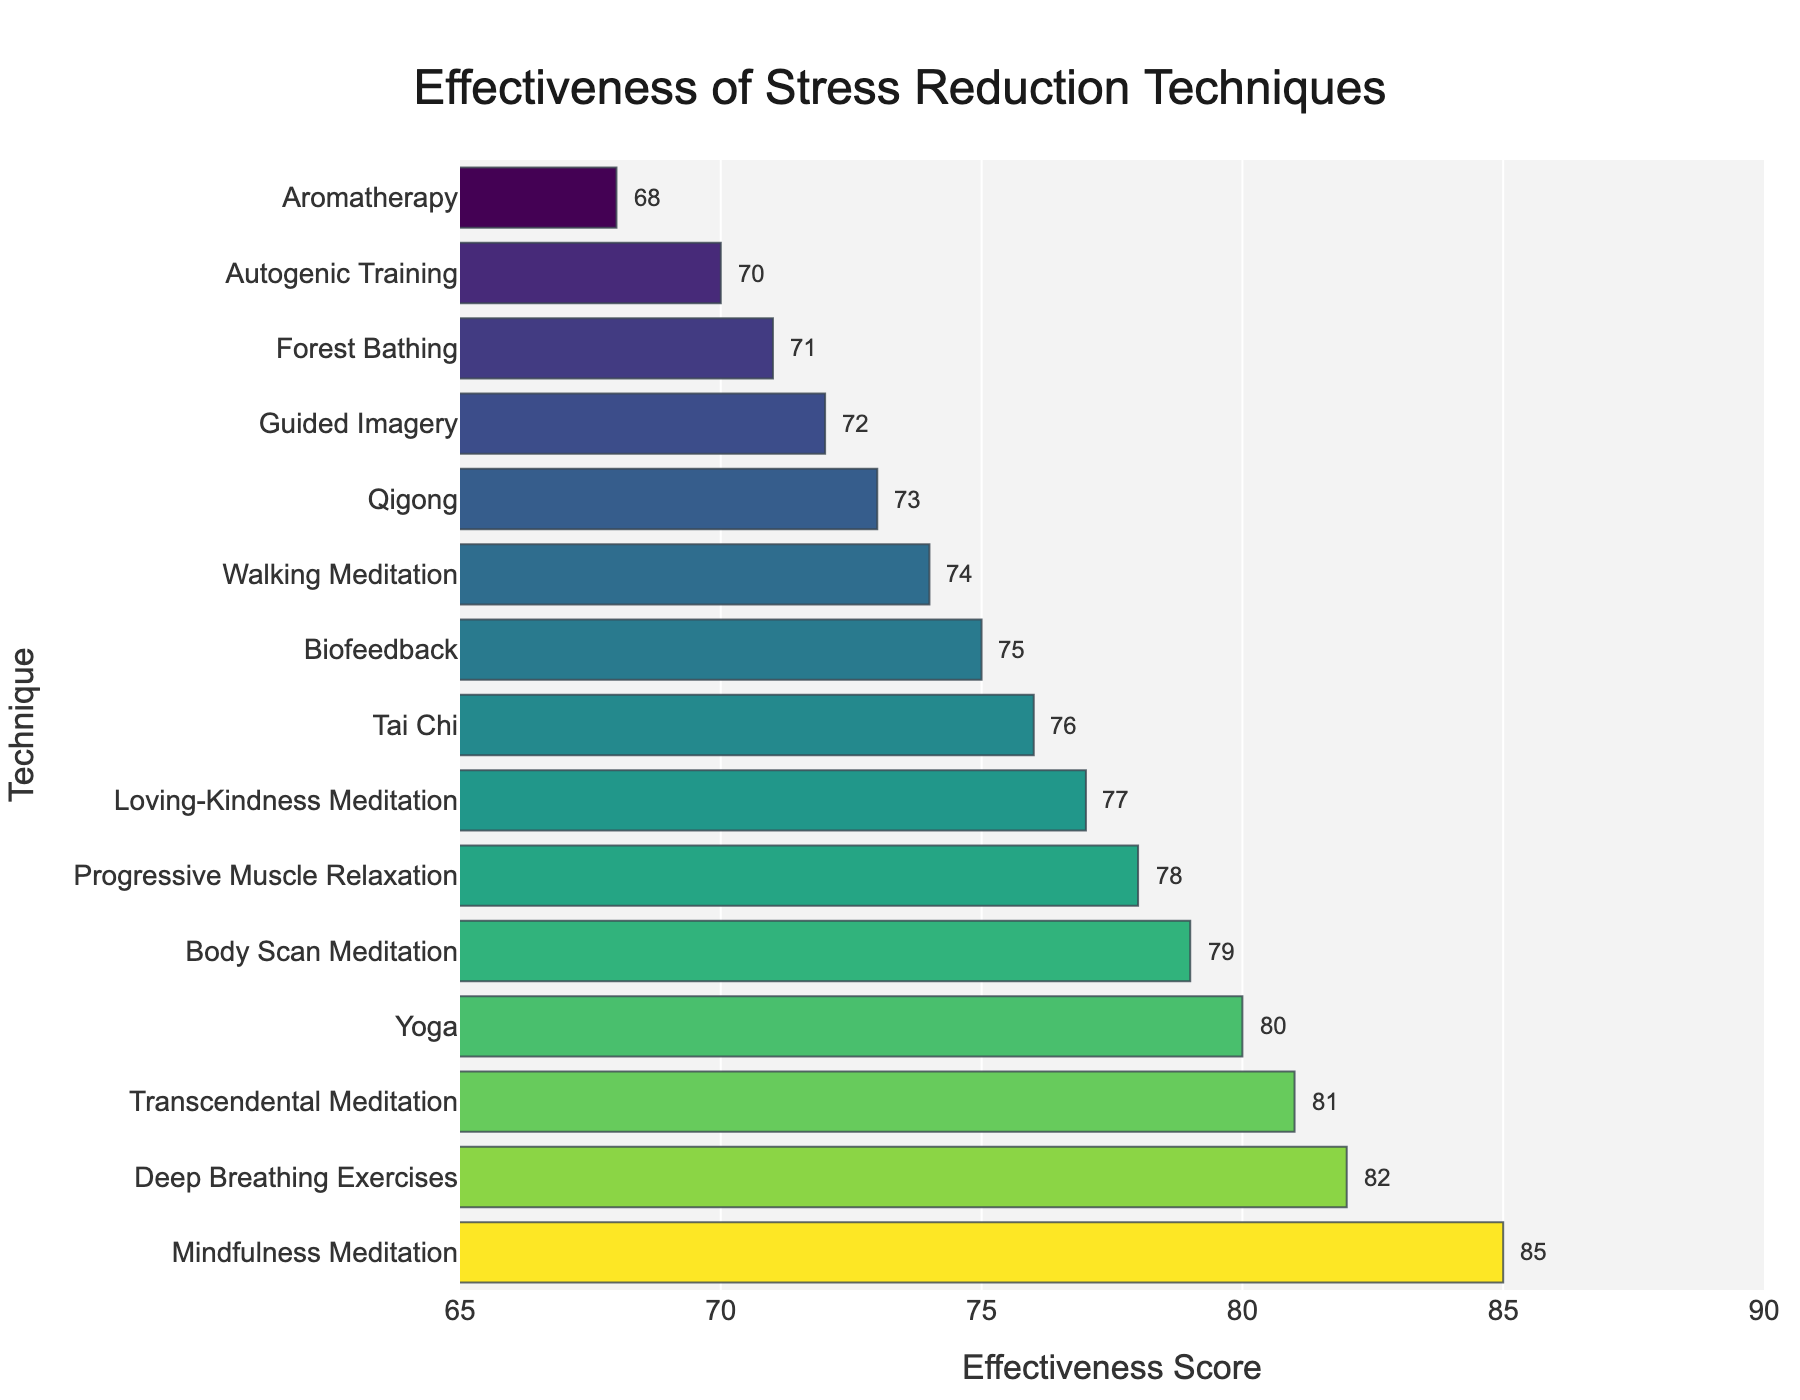Which technique has the highest effectiveness score? The bar chart shows the effectiveness scores of different stress reduction techniques, and the highest bar represents the technique with the highest score.
Answer: Mindfulness Meditation Which technique has the lowest effectiveness score? The bar chart shows various effectiveness scores, and the shortest bar represents the technique with the lowest score.
Answer: Aromatherapy How many techniques have an effectiveness score greater than 80? From the bar chart, count the number of bars that exceed the mark of 80 on the x-axis.
Answer: 4 Which techniques have an effectiveness score between 70 and 75? Identify all bars that fall within the range of 70 to 75 on the x-axis.
Answer: Forest Bathing, Qigong, Walking Meditation, Biofeedback Is Mindfulness Meditation more effective than Yoga? Compare the effectiveness scores of Mindfulness Meditation and Yoga by looking at the heights of their respective bars; Mindfulness Meditation's bar is higher.
Answer: Yes What is the average effectiveness score of all the techniques? Sum all the effectiveness scores listed and divide by the number of techniques.
Answer: 76.93 Which technique has an effectiveness score closest to 75? Find the bar that is nearest to the score of 75 on the x-axis.
Answer: Qigong How much higher is Deep Breathing Exercises' effectiveness score compared to Guided Imagery? Subtract Guided Imagery's effectiveness score from Deep Breathing Exercises' score (82 - 72).
Answer: 10 Which techniques have effectiveness scores less than 72? Identify all bars that have their heights below the mark of 72 on the x-axis.
Answer: Aromatherapy What are the top three most effective techniques for stress reduction according to the chart? Identify the three bars with the highest scores and read their labels.
Answer: Mindfulness Meditation, Deep Breathing Exercises, Transcendental Meditation 